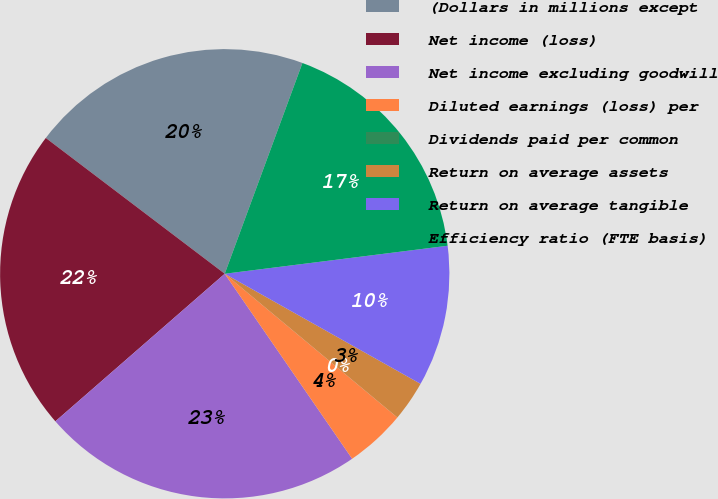Convert chart. <chart><loc_0><loc_0><loc_500><loc_500><pie_chart><fcel>(Dollars in millions except<fcel>Net income (loss)<fcel>Net income excluding goodwill<fcel>Diluted earnings (loss) per<fcel>Dividends paid per common<fcel>Return on average assets<fcel>Return on average tangible<fcel>Efficiency ratio (FTE basis)<nl><fcel>20.29%<fcel>21.74%<fcel>23.19%<fcel>4.35%<fcel>0.0%<fcel>2.9%<fcel>10.14%<fcel>17.39%<nl></chart> 